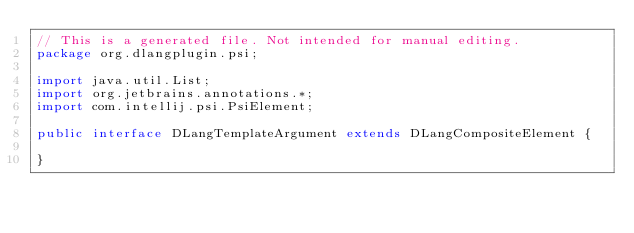Convert code to text. <code><loc_0><loc_0><loc_500><loc_500><_Java_>// This is a generated file. Not intended for manual editing.
package org.dlangplugin.psi;

import java.util.List;
import org.jetbrains.annotations.*;
import com.intellij.psi.PsiElement;

public interface DLangTemplateArgument extends DLangCompositeElement {

}
</code> 